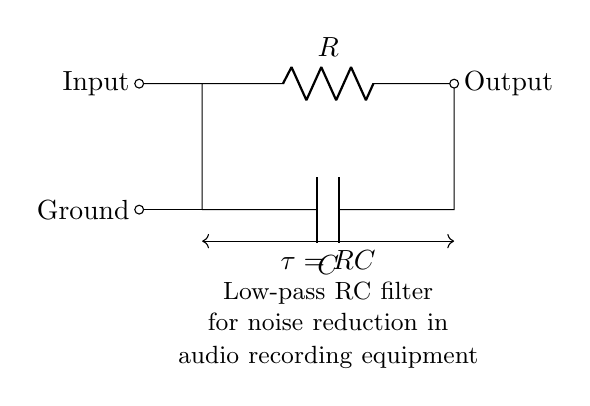What components are present in this circuit? The circuit consists of a resistor and a capacitor. The diagram clearly labels the components as R (for the resistor) and C (for the capacitor).
Answer: Resistor, Capacitor What type of filter does this circuit represent? The circuit is designed as a low-pass filter. This is indicated by the arrangement of the resistor and capacitor that allows low-frequency signals to pass while attenuating high-frequency ones.
Answer: Low-pass filter What is the time constant of this circuit? The time constant (tau) of the circuit, denoted as tau = RC, is given in the diagram where R and C represent the values of the resistor and capacitor, respectively.
Answer: RC Where is the input signal connected in the circuit? The input signal is connected to the top node of the resistor. This is where the voltage enters the circuit before being processed by the filter.
Answer: Top node (of the resistor) How does this circuit reduce noise in audio recordings? The low-pass filter allows only low-frequency signals to pass through while suppressing higher frequencies that typically represent noise. This is vital for maintaining audio quality.
Answer: By filtering high frequencies What is the role of the capacitor in this circuit? The capacitor works to smooth out voltage variations, allowing stable low-frequency signals to pass while blocking higher frequency noise and transients.
Answer: Smoothing voltage variations What happens if the resistance value is increased? Increasing the resistance will increase the time constant (tau), resulting in a slower response to changes in input voltage, which may further reduce high-frequency noise but can also lead to delayed signal processing.
Answer: Slower response 